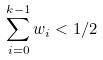Convert formula to latex. <formula><loc_0><loc_0><loc_500><loc_500>\sum _ { i = 0 } ^ { k - 1 } w _ { i } < 1 / 2</formula> 